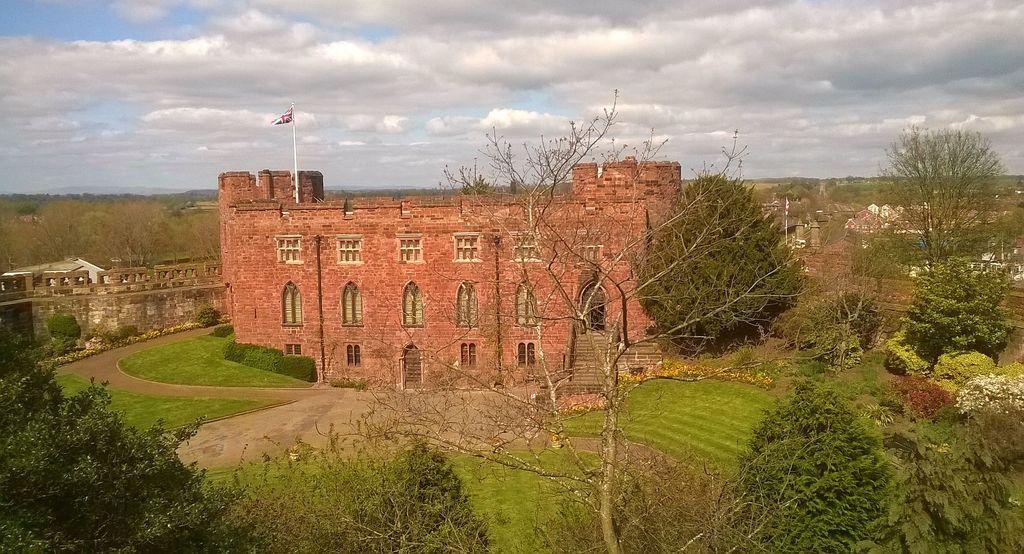Can you describe this image briefly? Here we can see trees,grass and plants and we can see building,wall and flag with pole. We can see sky with clouds. 